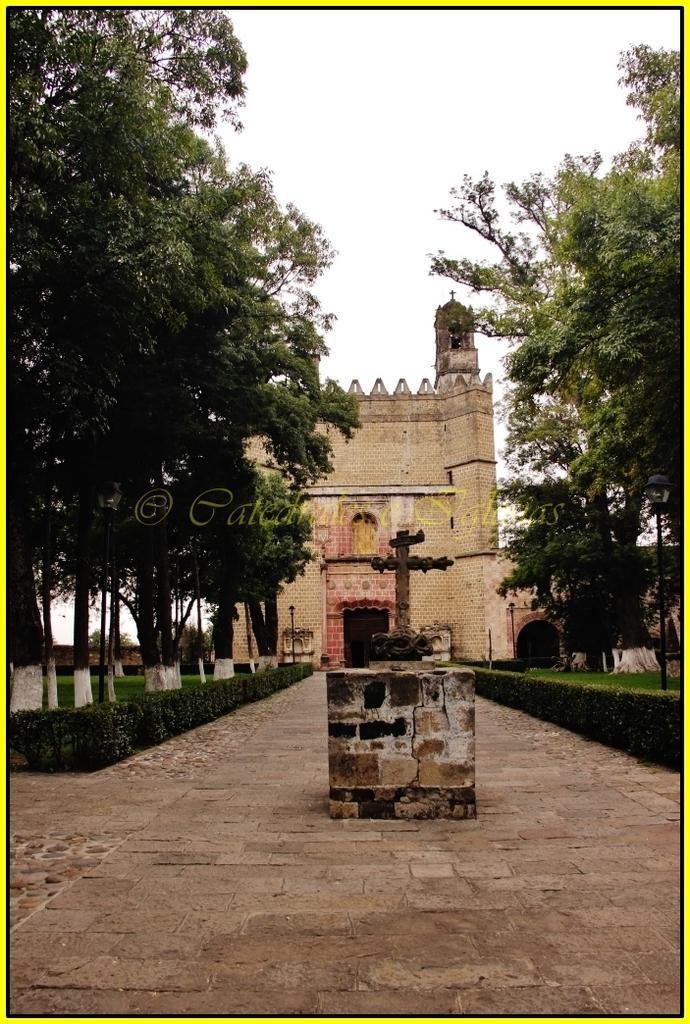Can you describe this image briefly? This picture shows a building and we see trees and a cloudy sky and we see few plants and we see a statue on the stone. 